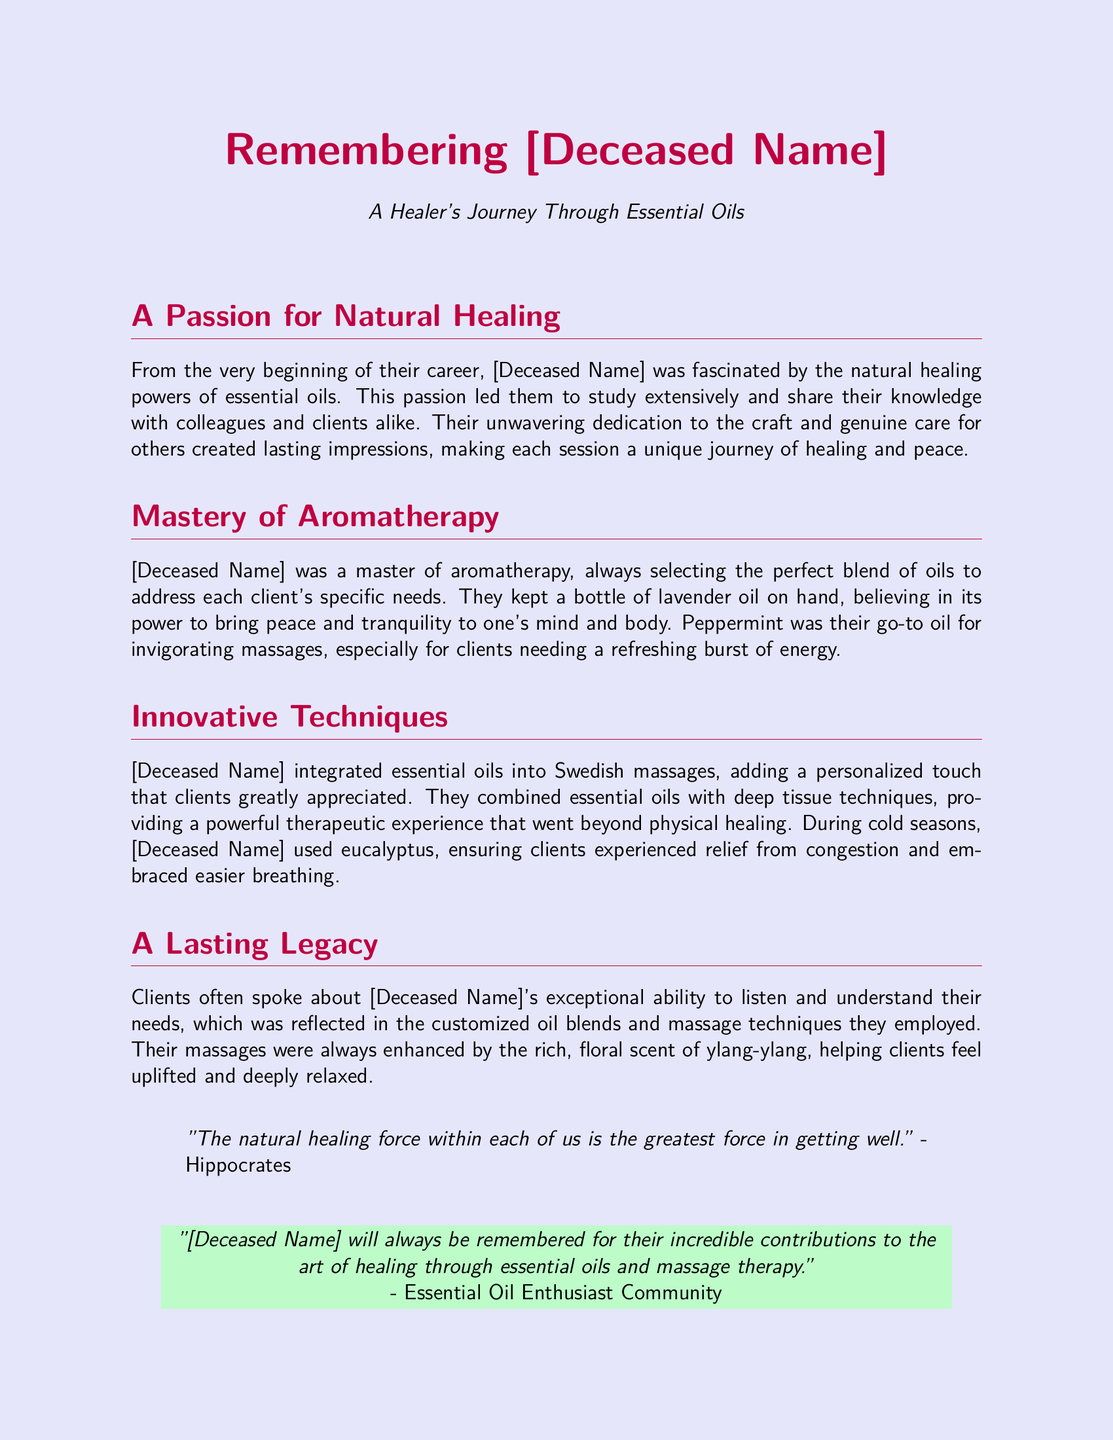What was [Deceased Name]'s primary profession? [Deceased Name] was a massage therapist who utilized essential oils in their practice.
Answer: massage therapist What essential oil did [Deceased Name] always keep on hand? The document mentions that [Deceased Name] kept a bottle of lavender oil on hand.
Answer: lavender oil Which essential oil was used for invigorating massages? The document states that peppermint was their go-to oil for invigorating massages.
Answer: peppermint What unique combination did [Deceased Name] use during massages? [Deceased Name] integrated essential oils with deep tissue techniques for a powerful therapeutic experience.
Answer: essential oils with deep tissue techniques What essential oil did [Deceased Name] use during cold seasons? The document indicates that eucalyptus was used by [Deceased Name] during cold seasons.
Answer: eucalyptus What was the belief associated with lavender oil? [Deceased Name] believed in lavender oil's ability to bring peace and tranquility.
Answer: peace and tranquility Who quoted, "The natural healing force within each of us is the greatest force in getting well”? The quote is attributed to Hippocrates in the document.
Answer: Hippocrates What community mentioned [Deceased Name]'s contributions? The Essential Oil Enthusiast Community recognized [Deceased Name]'s contributions in the document.
Answer: Essential Oil Enthusiast Community 